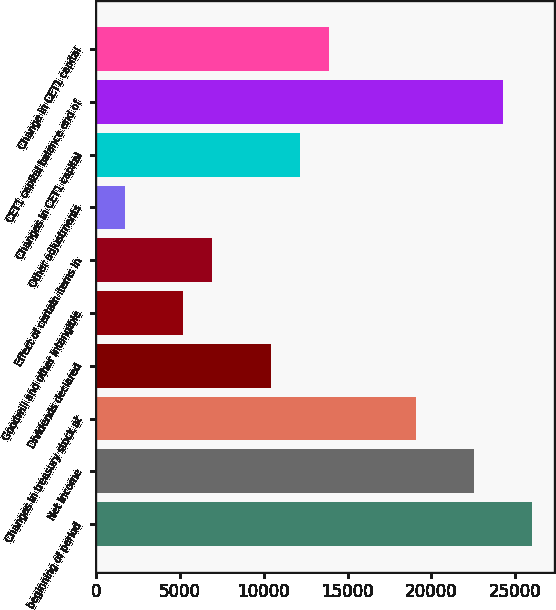Convert chart. <chart><loc_0><loc_0><loc_500><loc_500><bar_chart><fcel>beginning of period<fcel>Net income<fcel>Changes in treasury stock at<fcel>Dividends declared<fcel>Goodwill and other intangible<fcel>Effect of certain items in<fcel>Other adjustments<fcel>Changes in CET1 capital<fcel>CET1 capital balance end of<fcel>Change in CET1 capital<nl><fcel>26020<fcel>22551.6<fcel>19083.2<fcel>10412.2<fcel>5209.6<fcel>6943.8<fcel>1741.2<fcel>12146.4<fcel>24285.8<fcel>13880.6<nl></chart> 